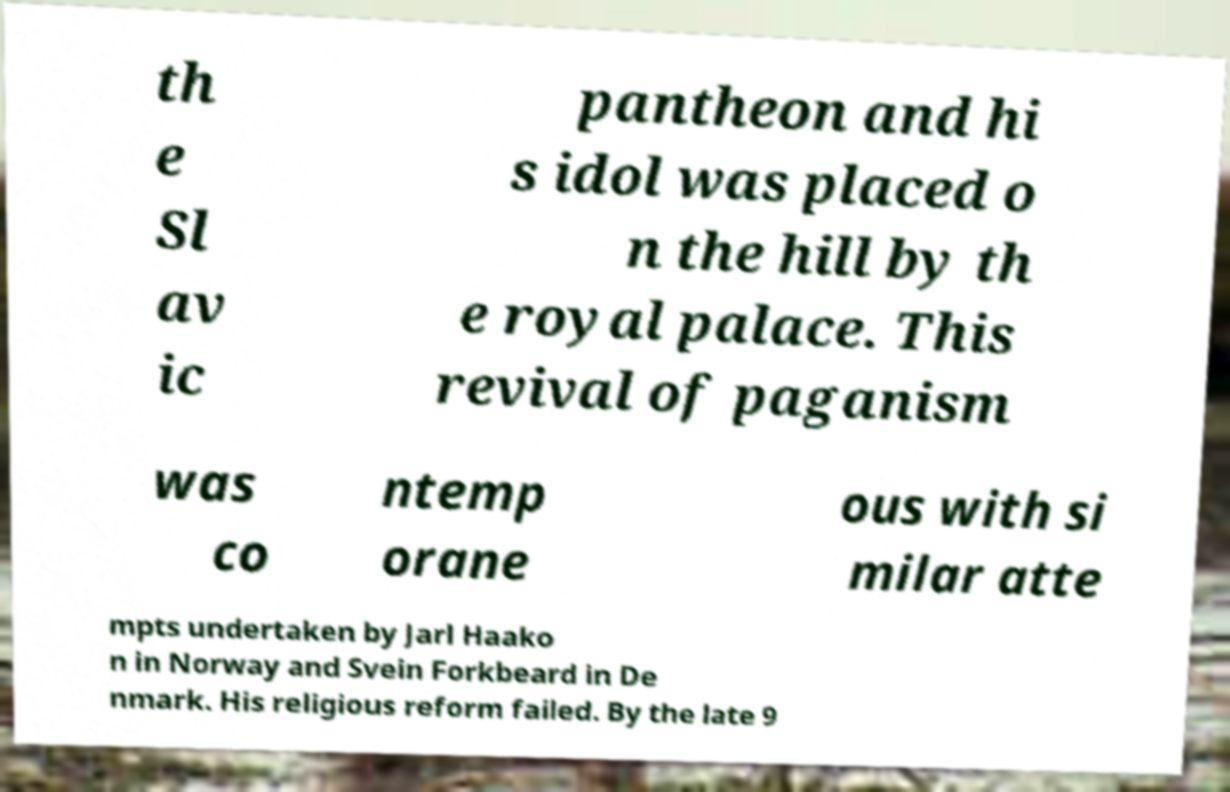For documentation purposes, I need the text within this image transcribed. Could you provide that? th e Sl av ic pantheon and hi s idol was placed o n the hill by th e royal palace. This revival of paganism was co ntemp orane ous with si milar atte mpts undertaken by Jarl Haako n in Norway and Svein Forkbeard in De nmark. His religious reform failed. By the late 9 